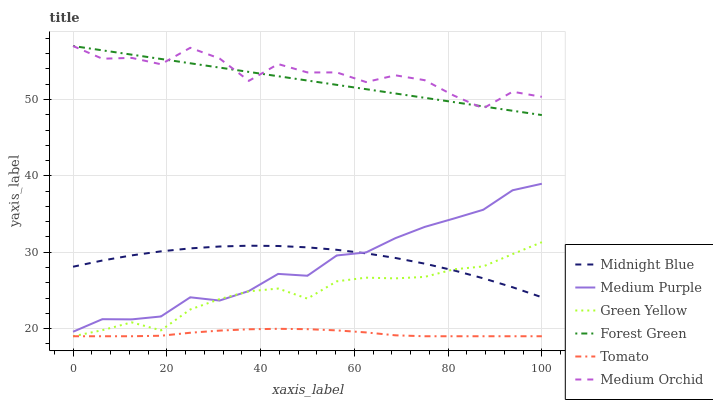Does Midnight Blue have the minimum area under the curve?
Answer yes or no. No. Does Midnight Blue have the maximum area under the curve?
Answer yes or no. No. Is Midnight Blue the smoothest?
Answer yes or no. No. Is Midnight Blue the roughest?
Answer yes or no. No. Does Midnight Blue have the lowest value?
Answer yes or no. No. Does Midnight Blue have the highest value?
Answer yes or no. No. Is Green Yellow less than Medium Orchid?
Answer yes or no. Yes. Is Forest Green greater than Midnight Blue?
Answer yes or no. Yes. Does Green Yellow intersect Medium Orchid?
Answer yes or no. No. 